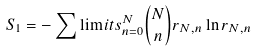Convert formula to latex. <formula><loc_0><loc_0><loc_500><loc_500>S _ { 1 } = - \sum \lim i t s ^ { N } _ { n = 0 } \binom { N } { n } r _ { N , n } \ln { r _ { N , n } }</formula> 